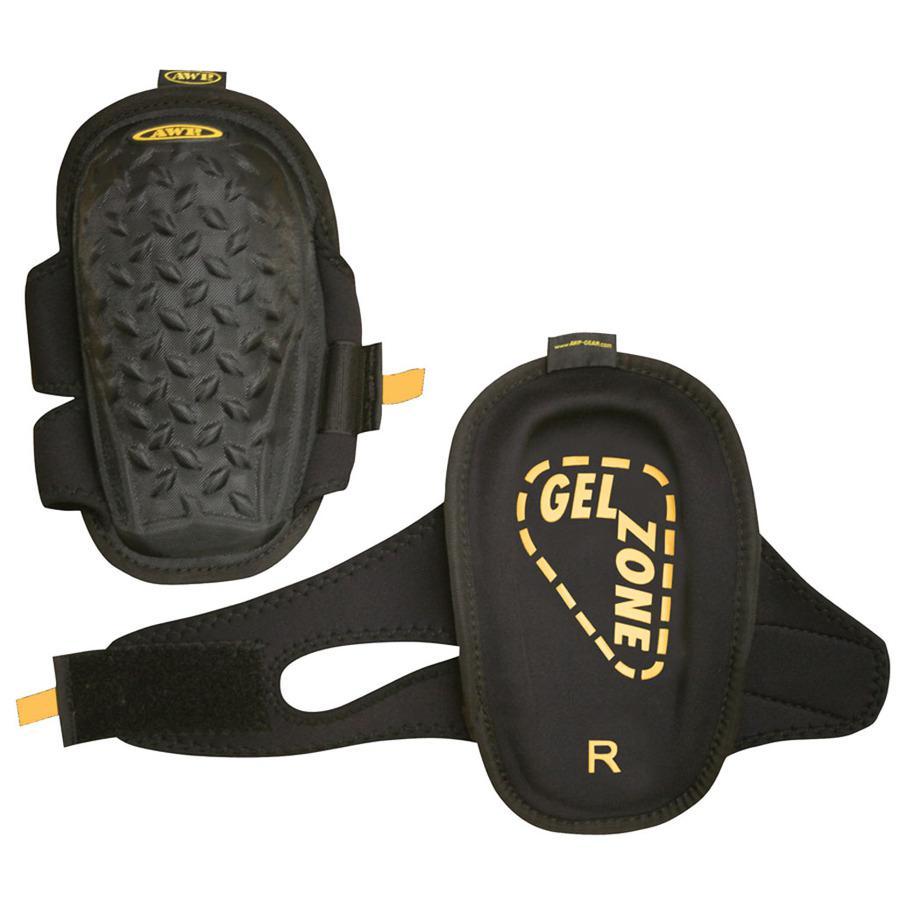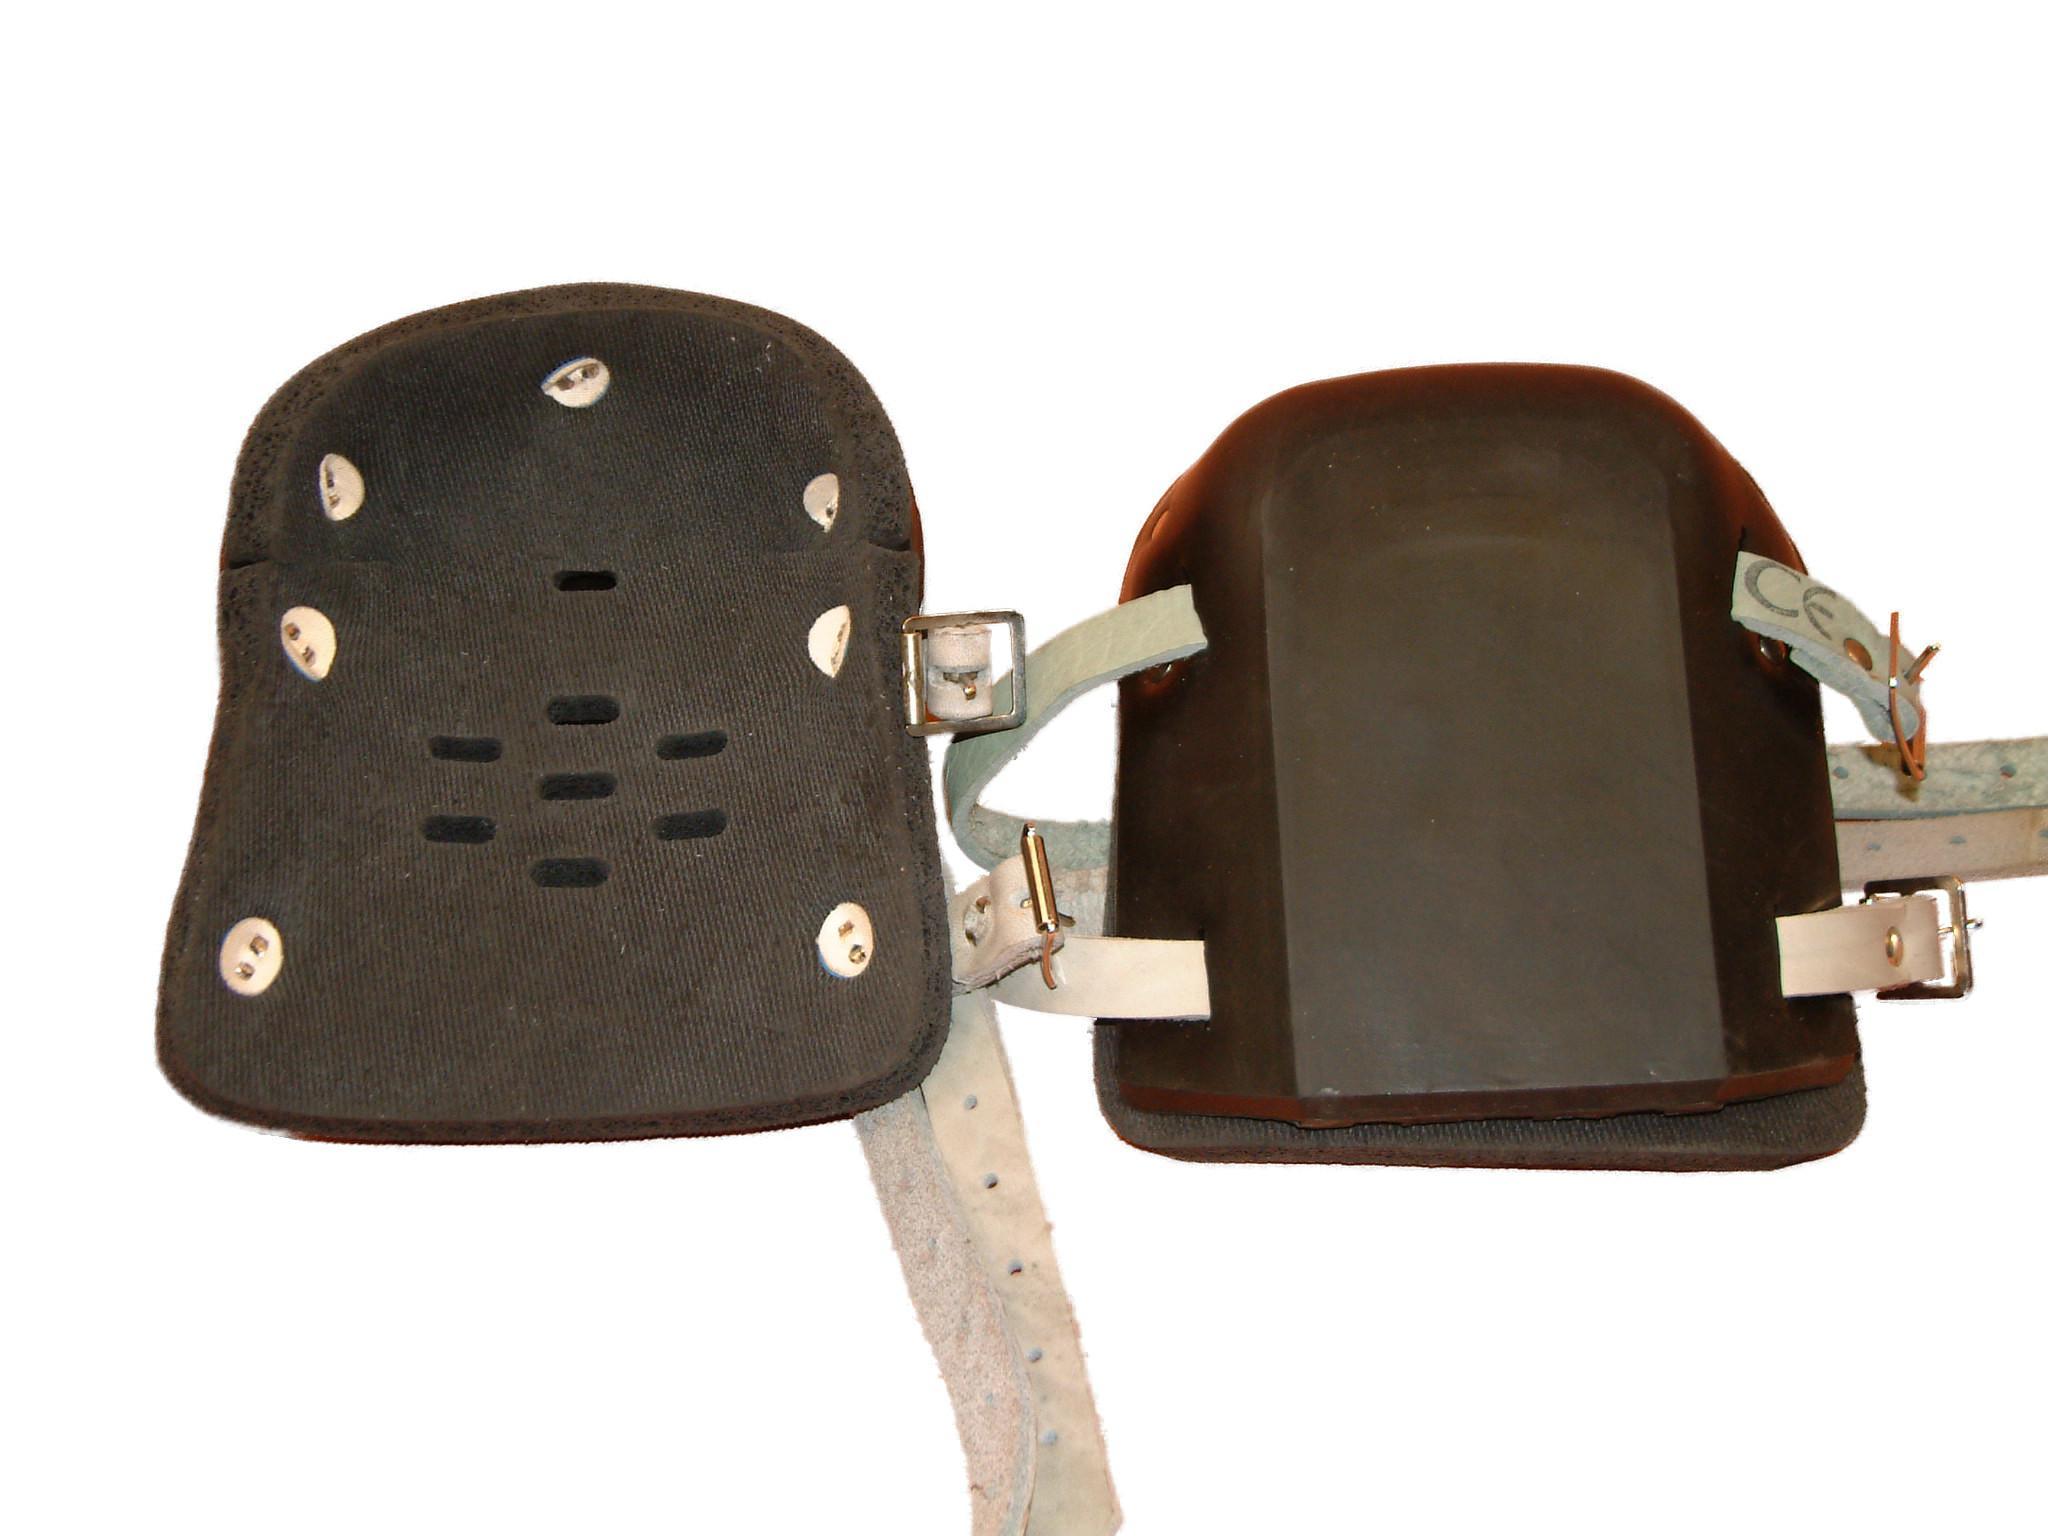The first image is the image on the left, the second image is the image on the right. For the images displayed, is the sentence "There are two charcoal colored knee pads with similar colored straps in the image on the right." factually correct? Answer yes or no. No. The first image is the image on the left, the second image is the image on the right. Analyze the images presented: Is the assertion "The kneepads on the left are brown and black, and the pair on the right are solid black." valid? Answer yes or no. No. 